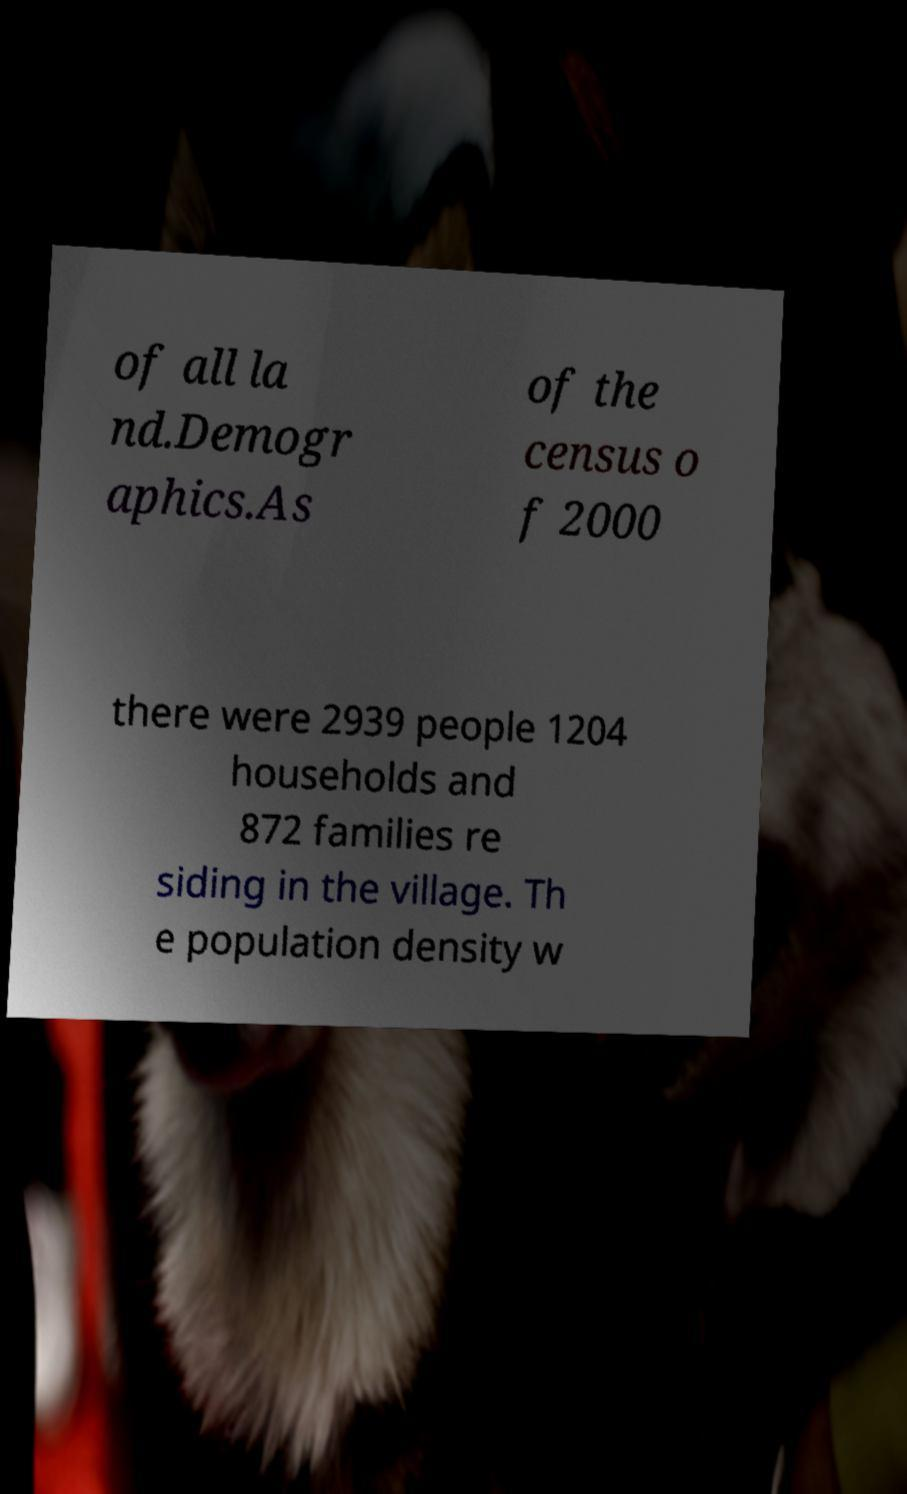There's text embedded in this image that I need extracted. Can you transcribe it verbatim? of all la nd.Demogr aphics.As of the census o f 2000 there were 2939 people 1204 households and 872 families re siding in the village. Th e population density w 